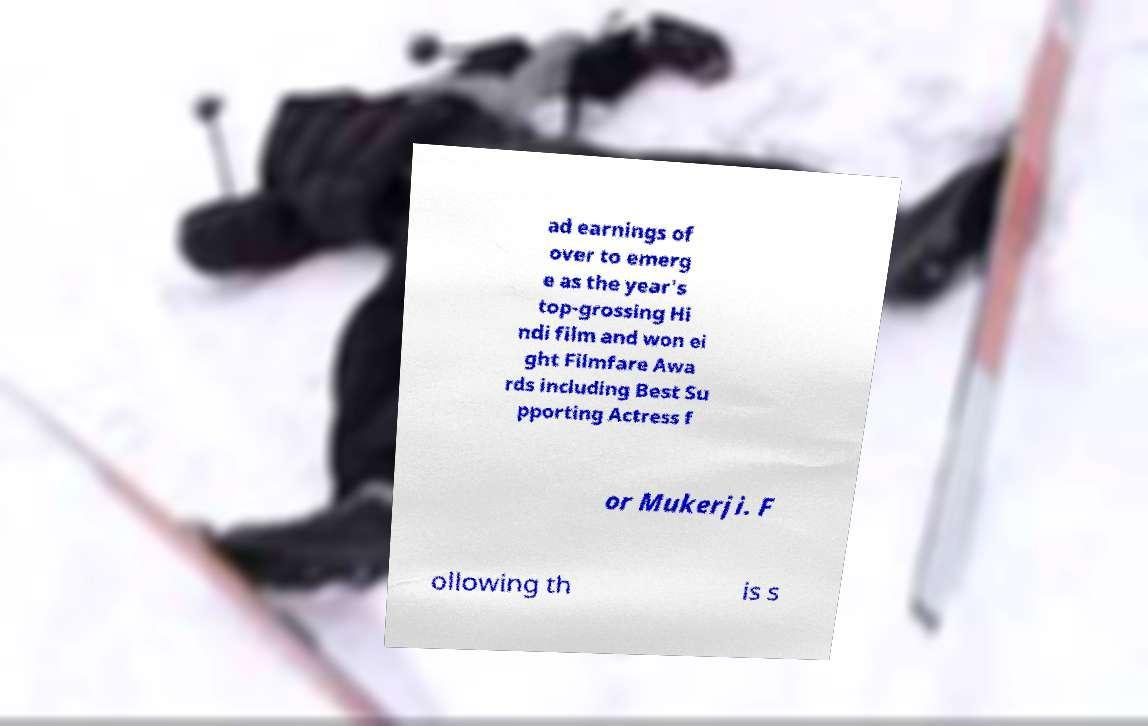Can you read and provide the text displayed in the image?This photo seems to have some interesting text. Can you extract and type it out for me? ad earnings of over to emerg e as the year's top-grossing Hi ndi film and won ei ght Filmfare Awa rds including Best Su pporting Actress f or Mukerji. F ollowing th is s 